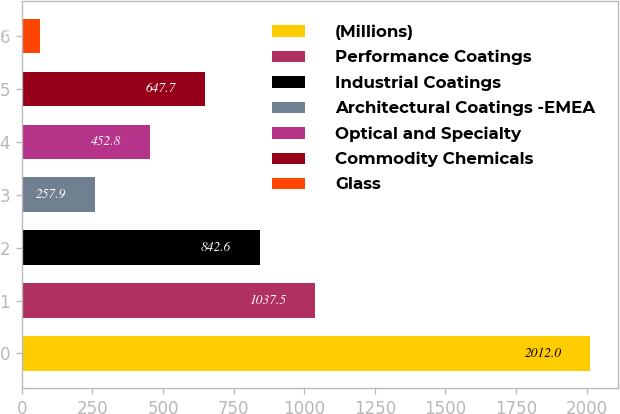Convert chart to OTSL. <chart><loc_0><loc_0><loc_500><loc_500><bar_chart><fcel>(Millions)<fcel>Performance Coatings<fcel>Industrial Coatings<fcel>Architectural Coatings -EMEA<fcel>Optical and Specialty<fcel>Commodity Chemicals<fcel>Glass<nl><fcel>2012<fcel>1037.5<fcel>842.6<fcel>257.9<fcel>452.8<fcel>647.7<fcel>63<nl></chart> 